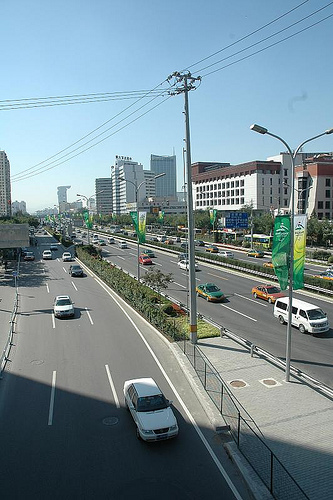<image>
Is there a van behind the pole? Yes. From this viewpoint, the van is positioned behind the pole, with the pole partially or fully occluding the van. Where is the electric line in relation to the sky? Is it in front of the sky? Yes. The electric line is positioned in front of the sky, appearing closer to the camera viewpoint. 